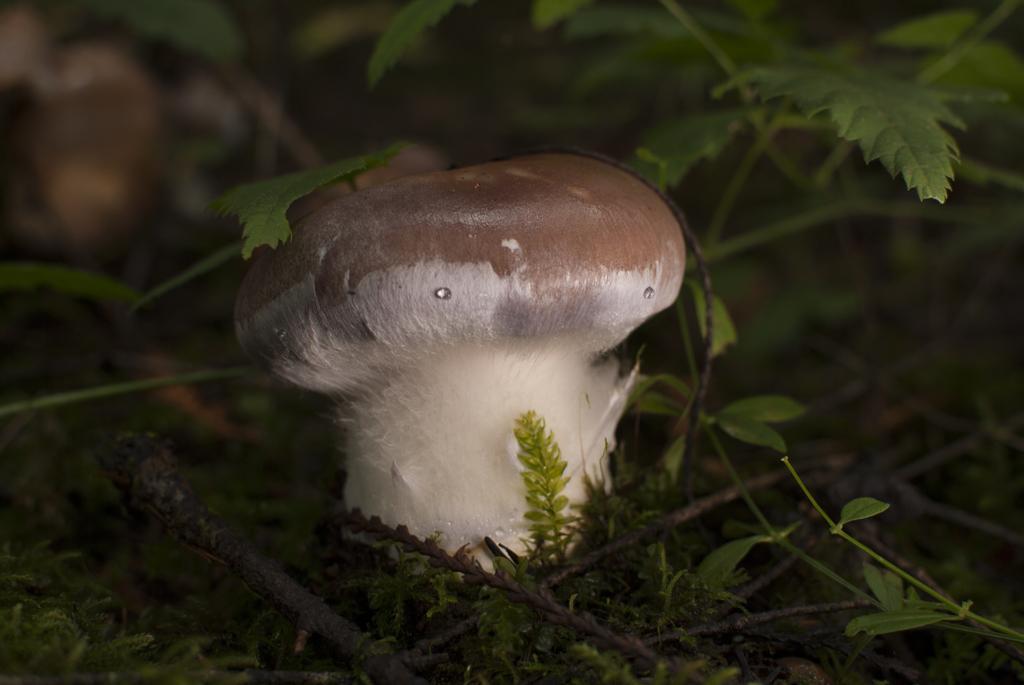Please provide a concise description of this image. In this image we can see a mushroom. We can also see some leaves to the studs around it. 